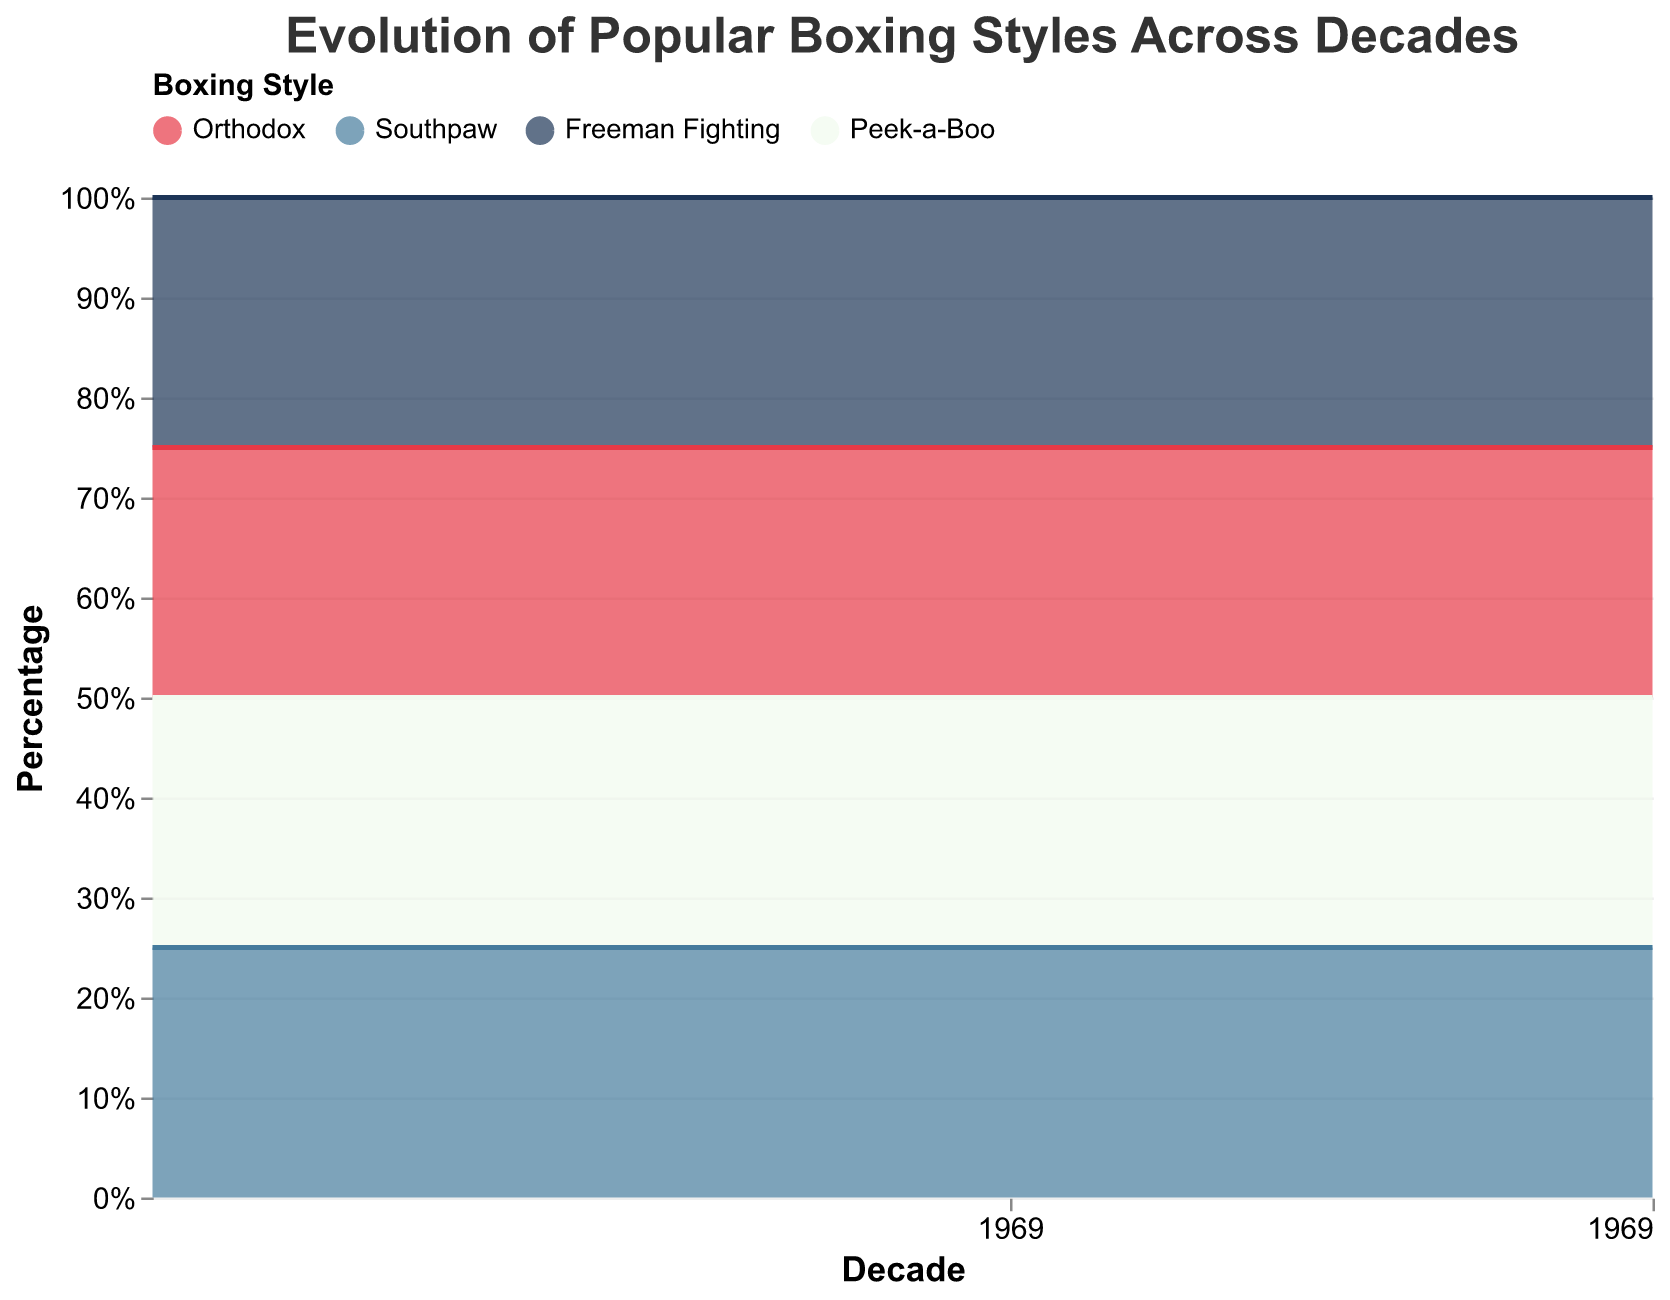Which boxing style had the highest popularity in 1950? In 1950, the percentage of different boxing styles were: Orthodox (60%), Southpaw (5%), Freeman Fighting (30%), Peek-a-Boo (5%). Orthodox had the highest percentage.
Answer: Orthodox Which decade saw the largest increase in popularity of the Southpaw style? Comparing the increase in percentages across each decade, Southpaw increased by 2% (1960s), 3% (1970s), 2% (1980s), 3% (1990s), 3% (2000s), 2% (2010s). The largest increase was in the 1990s, from 12% to 15%.
Answer: 1990s How did the popularity of Freeman Fighting change from 1950 to 2020? The percentage of Freeman Fighting decreased from 30% in 1950 to 20% in 2020.
Answer: Decreased Which style became more popular over time, Peek-a-Boo or Southpaw? Over the decades, the percentage of Peek-a-Boo increased from 5% to 15%, while Southpaw increased from 5% to 23%. Both became more popular, but Southpaw had a greater increase.
Answer: Southpaw What was the trend for the Orthodox style over the decades? Observing the graph, Orthodox's percentage consistently decreased from 60% in 1950 to 42% in 2020.
Answer: Decreasing What is the percentage difference between the Orthodox and Peek-a-Boo style in 2020? In 2020, Orthodox was 42% and Peek-a-Boo was 15%. The difference is 42% - 15% = 27%.
Answer: 27% During which decade did Peek-a-Boo style surpass 10% for the first time? According to the data, Peek-a-Boo reached 12% in 2010, which is the first instance it surpassed 10%.
Answer: 2010 Compare the popularity of Freeman Fighting and Orthodox styles in 1990. In 1990, the percentage for Freeman Fighting was 28%, and for Orthodox, it was 50%. Orthodox was more popular.
Answer: Orthodox Which style had a consistent growth trend from 1950 to 2020? Both Peek-a-Boo and Southpaw showed consistent growth. However, Southpaw had a clearer growth trajectory rising from 5% to 23%.
Answer: Southpaw What is the overall trend for all styles by observing the stacked area chart? Orthodox is decreasing, Freeman Fighting shows slight decrease, while Southpaw and Peek-a-Boo are increasing over the decades.
Answer: Mixed 